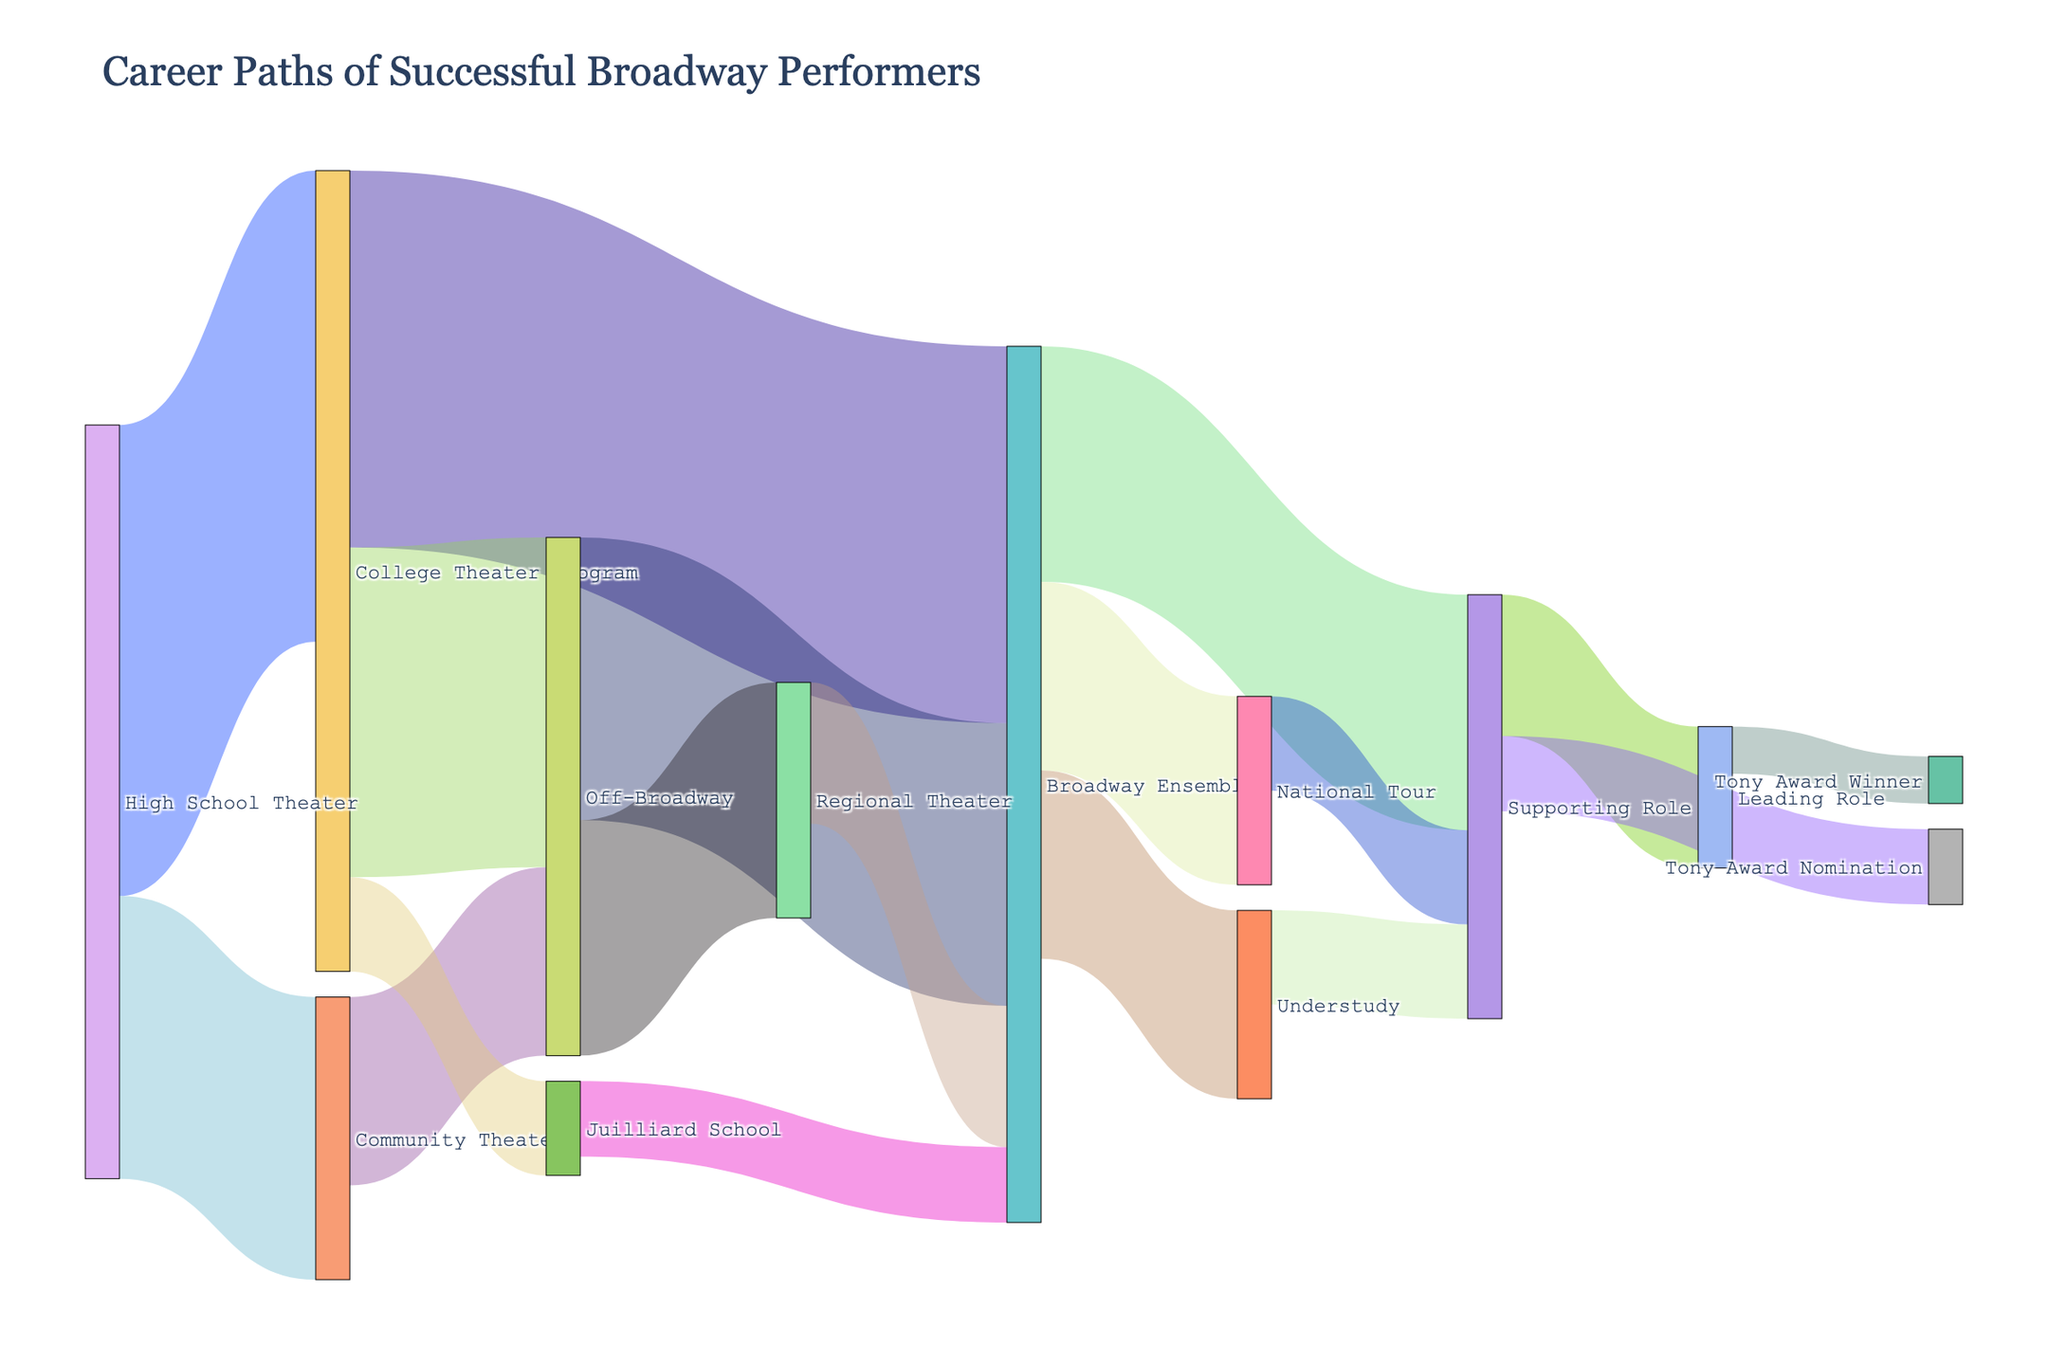What's the title of the figure? The title is displayed at the top center of the figure to give viewers an overview of what the diagram represents.
Answer: Career Paths of Successful Broadway Performers How many performers transitioned from "High School Theater" to "College Theater Program"? The diagram visualizes connections between nodes with labeled values. The link from "High School Theater" to "College Theater Program" shows the value as 50.
Answer: 50 What is the total number of performers who reached a "Broadway Ensemble" role? To find the total, sum up all incoming connections to the "Broadway Ensemble". From "College Theater Program" (40), "Off-Broadway" (30), "Juilliard School" (8), and "Regional Theater" (15), the total is 40 + 30 + 8 + 15 = 93.
Answer: 93 Which pathway had the least number of performers leading to a "Broadway Ensemble" role? Compare all the pathways leading to "Broadway Ensemble". The values are: "College Theater Program" (40), "Off-Broadway" (30), "Juilliard School" (8), and "Regional Theater" (15). The smallest is 8 from "Juilliard School".
Answer: From Juilliard School Between "Off-Broadway" and "Community Theater", which pathway led more performers to "Broadway Ensemble"? Compare the values for paths leading to "Broadway Ensemble". "Off-Broadway" leads 30 performers, while "Community Theater" (indirectly via other paths) is less direct. Direct values should be used for a clear comparison.
Answer: Off-Broadway How many total Tony Award nominees are there in the diagram? Find all the paths leading to "Tony Award Nomination" and sum the values. There is only one path, "Supporting Role" to "Tony Award Nomination" with a value of 8.
Answer: 8 From "Supporting Role", what percentage of performers went on to win a Tony Award? Calculate the percentage from "Supporting Role" to "Tony Award Winner". From "Supporting Role" to "Tony Award Winner" is 5, and to "Tony Award Nomination" is 8. Percentage = (5 / 8) * 100 = 62.5%.
Answer: 62.5% What is the sum of performers who transitioned to "Off-Broadway" from either "College Theater Program" or "Community Theater"? Add the two values for paths leading to "Off-Broadway". From "College Theater Program" (35) and "Community Theater" (20), the total is 35 + 20 = 55.
Answer: 55 Which pathway leads directly to a "Leading Role"? Identify all direct connections leading to "Leading Role". There is only one direct pathway shown, from "Supporting Role" to "Leading Role".
Answer: From Supporting Role How many more performers transitioned from "High School Theater" to "College Theater Program" compared to those who went to "Community Theater"? Subtract the value of the "High School Theater" to "Community Theater" path from the "High School Theater" to "College Theater Program" path. It’s 50 - 30 = 20.
Answer: 20 